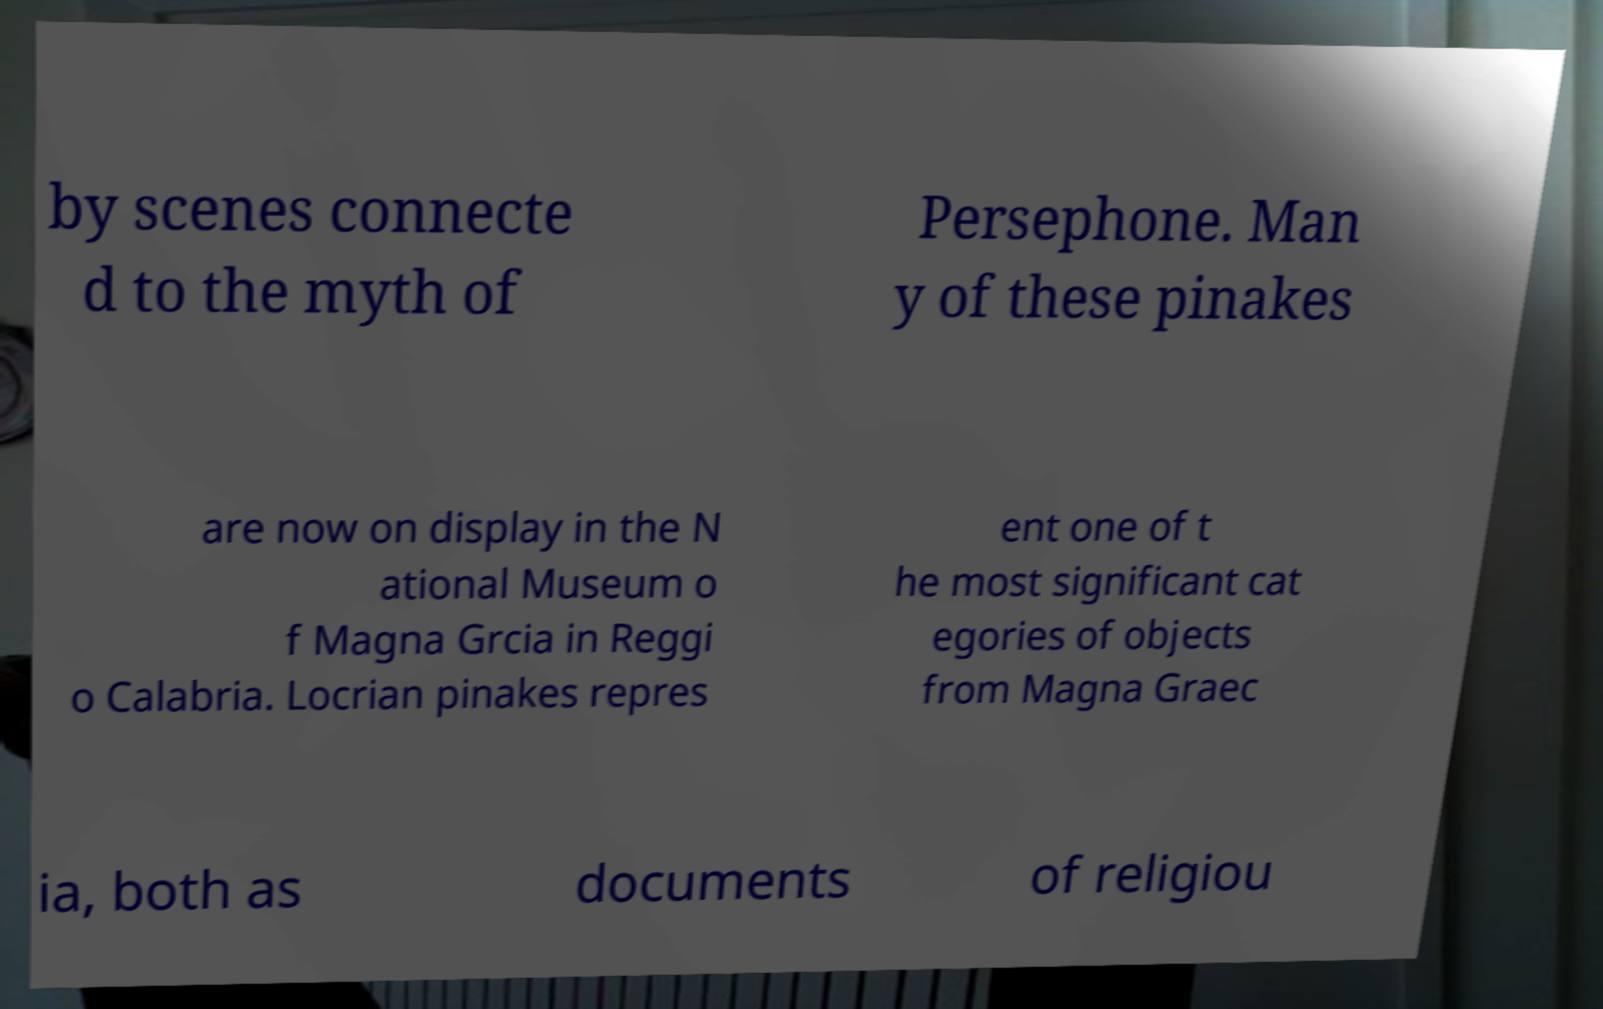Could you assist in decoding the text presented in this image and type it out clearly? by scenes connecte d to the myth of Persephone. Man y of these pinakes are now on display in the N ational Museum o f Magna Grcia in Reggi o Calabria. Locrian pinakes repres ent one of t he most significant cat egories of objects from Magna Graec ia, both as documents of religiou 